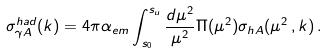Convert formula to latex. <formula><loc_0><loc_0><loc_500><loc_500>\sigma _ { \gamma A } ^ { h a d } ( k ) = 4 \pi \alpha _ { e m } \int ^ { s _ { u } } _ { s _ { 0 } } \frac { d \mu ^ { 2 } } { \mu ^ { 2 } } \Pi ( \mu ^ { 2 } ) \sigma _ { h A } ( \mu ^ { 2 } \, , k ) \, .</formula> 